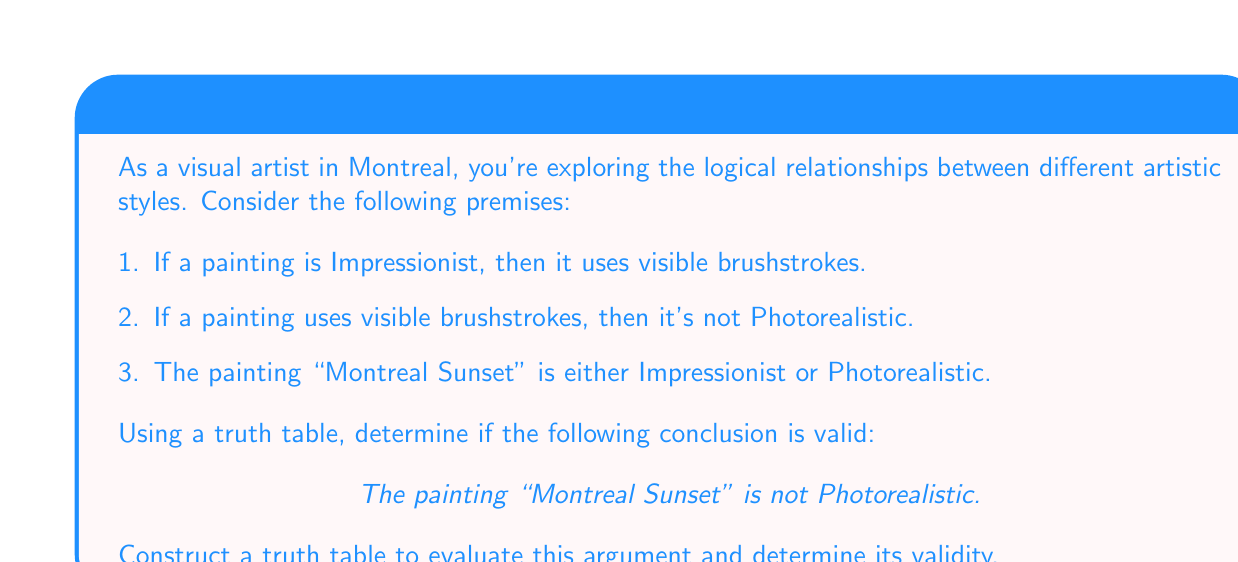Provide a solution to this math problem. Let's approach this step-by-step:

1. First, we need to identify our propositions:
   $p$: The painting is Impressionist
   $q$: The painting uses visible brushstrokes
   $r$: The painting is Photorealistic

2. Now, we can translate our premises into logical statements:
   Premise 1: $p \rightarrow q$
   Premise 2: $q \rightarrow \neg r$
   Premise 3: $p \lor r$

3. Our conclusion is: $\neg r$

4. We'll construct a truth table with columns for $p$, $q$, $r$, and each of our premises and conclusion:

   $$
   \begin{array}{|c|c|c|c|c|c|c|}
   \hline
   p & q & r & p \rightarrow q & q \rightarrow \neg r & p \lor r & \neg r \\
   \hline
   T & T & T & T & F & T & F \\
   T & T & F & T & T & T & T \\
   T & F & T & F & T & T & F \\
   T & F & F & F & T & T & T \\
   F & T & T & T & F & T & F \\
   F & T & F & T & T & F & T \\
   F & F & T & T & T & T & F \\
   F & F & F & T & T & F & T \\
   \hline
   \end{array}
   $$

5. For the argument to be valid, in every row where all premises are true (T), the conclusion must also be true.

6. We can see that there's only one row where all premises are true:
   $p = T$, $q = T$, $r = F$

7. In this row, the conclusion $\neg r$ is also true.

Therefore, the argument is valid. Whenever all the premises are true, the conclusion is necessarily true as well.
Answer: The argument is valid. The truth table demonstrates that when all premises are true, the conclusion is also true, confirming the logical validity of the argument. 